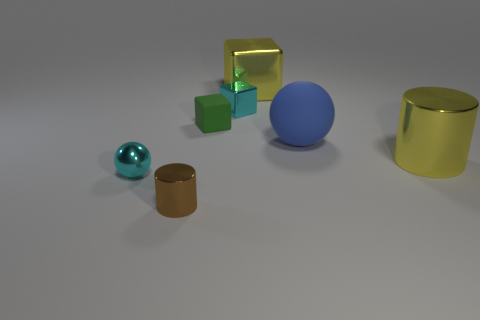Add 2 rubber objects. How many objects exist? 9 Subtract all spheres. How many objects are left? 5 Add 2 small brown objects. How many small brown objects exist? 3 Subtract 0 brown balls. How many objects are left? 7 Subtract all rubber things. Subtract all spheres. How many objects are left? 3 Add 3 green objects. How many green objects are left? 4 